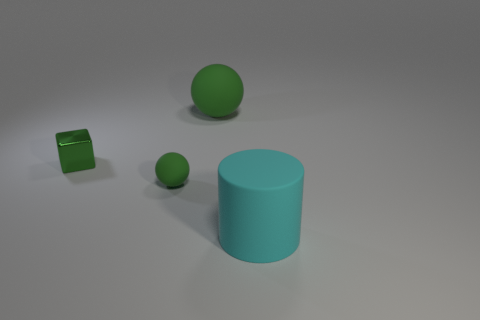How many objects are blue things or matte objects in front of the green shiny thing?
Offer a terse response. 2. Do the green sphere that is behind the shiny object and the small shiny thing have the same size?
Your response must be concise. No. The tiny matte ball has what color?
Make the answer very short. Green. There is a big thing behind the large cyan matte object; what is it made of?
Offer a terse response. Rubber. Are there the same number of big things right of the big matte cylinder and large purple metal blocks?
Provide a short and direct response. Yes. Does the big cyan thing have the same shape as the big green rubber thing?
Keep it short and to the point. No. Is there any other thing that is the same color as the small rubber object?
Give a very brief answer. Yes. What shape is the matte object that is both behind the large cyan cylinder and right of the small green sphere?
Provide a short and direct response. Sphere. Are there the same number of large cyan matte things on the right side of the big cylinder and tiny rubber balls right of the small green metal cube?
Ensure brevity in your answer.  No. How many balls are large brown shiny things or shiny things?
Provide a short and direct response. 0. 